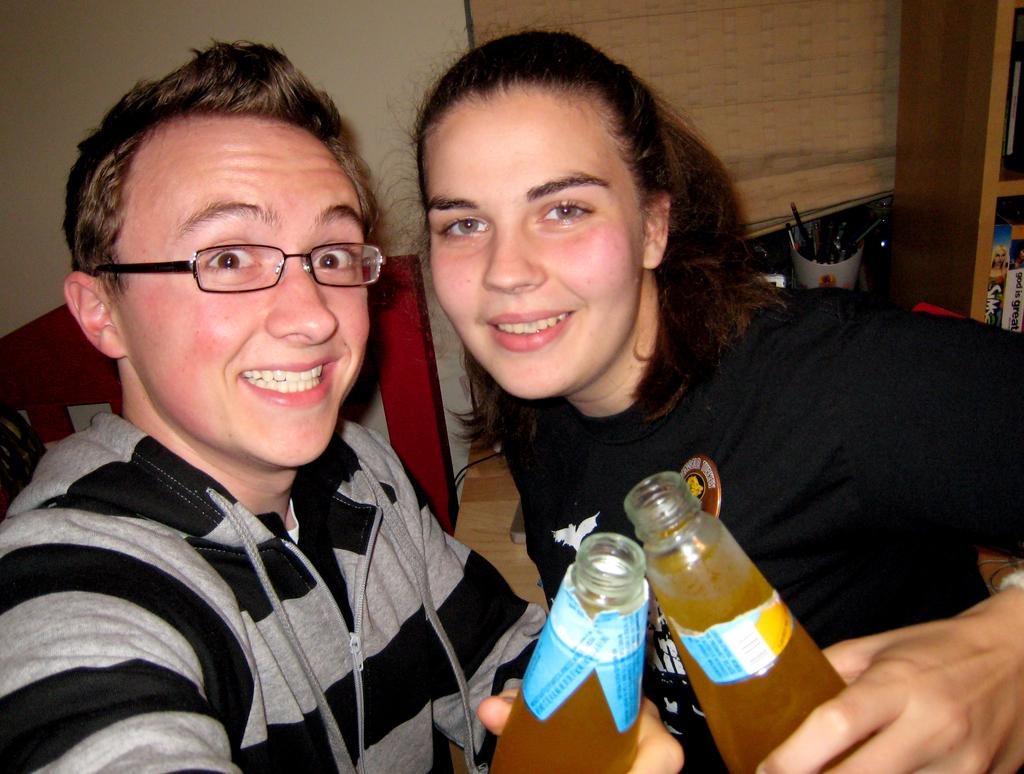Who is present in the image? There is a man and a woman in the image. What are the man and woman doing in the image? The man and woman are holding a soft drink bottle. What is the facial expression of the man and woman in the image? The man and woman are smiling. What type of furniture is being used to support the oil in the image? There is no furniture or oil present in the image; it features a man and a woman holding a soft drink bottle and smiling. 